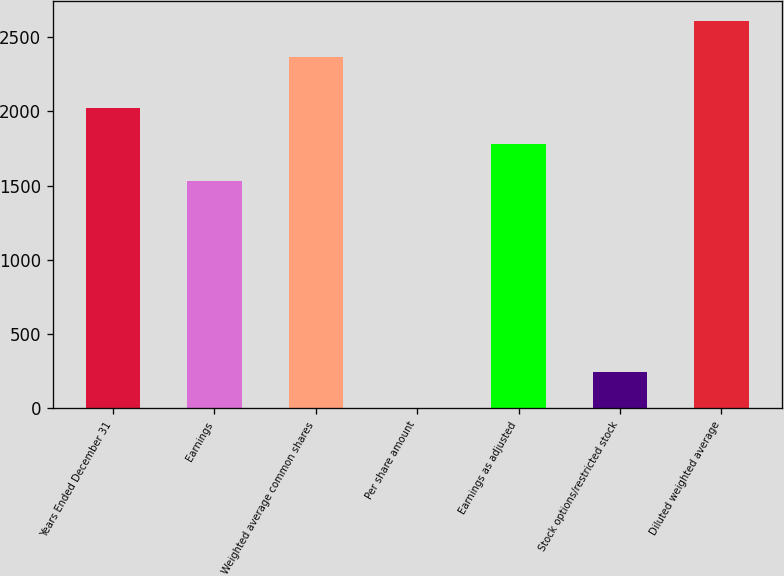Convert chart to OTSL. <chart><loc_0><loc_0><loc_500><loc_500><bar_chart><fcel>Years Ended December 31<fcel>Earnings<fcel>Weighted average common shares<fcel>Per share amount<fcel>Earnings as adjusted<fcel>Stock options/restricted stock<fcel>Diluted weighted average<nl><fcel>2026.27<fcel>1532<fcel>2365<fcel>0.65<fcel>1779.13<fcel>247.78<fcel>2612.14<nl></chart> 